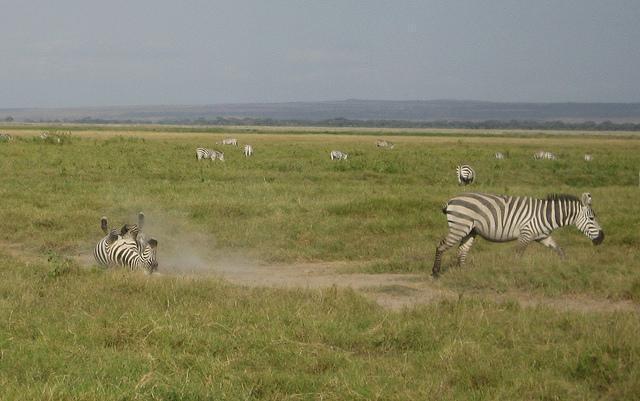How many species are shown?
Give a very brief answer. 1. How many zebras are there?
Give a very brief answer. 2. 